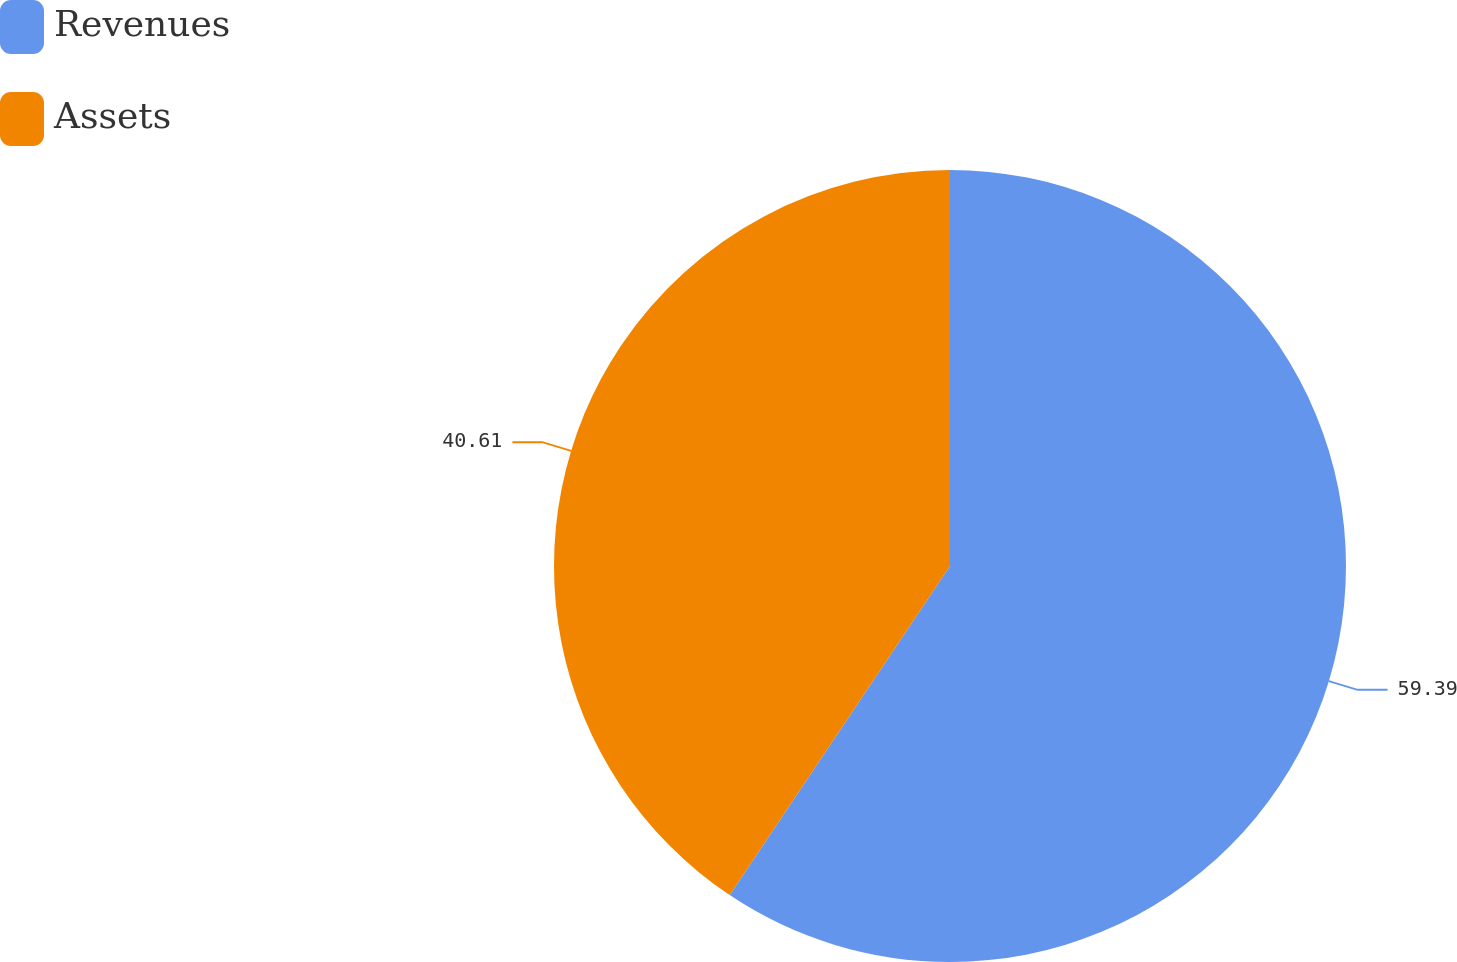Convert chart to OTSL. <chart><loc_0><loc_0><loc_500><loc_500><pie_chart><fcel>Revenues<fcel>Assets<nl><fcel>59.39%<fcel>40.61%<nl></chart> 